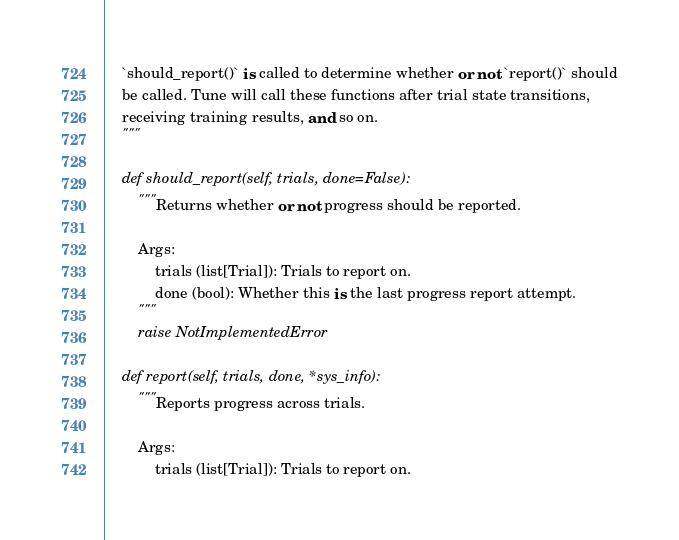Convert code to text. <code><loc_0><loc_0><loc_500><loc_500><_Python_>    `should_report()` is called to determine whether or not `report()` should
    be called. Tune will call these functions after trial state transitions,
    receiving training results, and so on.
    """

    def should_report(self, trials, done=False):
        """Returns whether or not progress should be reported.

        Args:
            trials (list[Trial]): Trials to report on.
            done (bool): Whether this is the last progress report attempt.
        """
        raise NotImplementedError

    def report(self, trials, done, *sys_info):
        """Reports progress across trials.

        Args:
            trials (list[Trial]): Trials to report on.</code> 